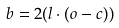<formula> <loc_0><loc_0><loc_500><loc_500>b = 2 ( l \cdot ( o - c ) )</formula> 